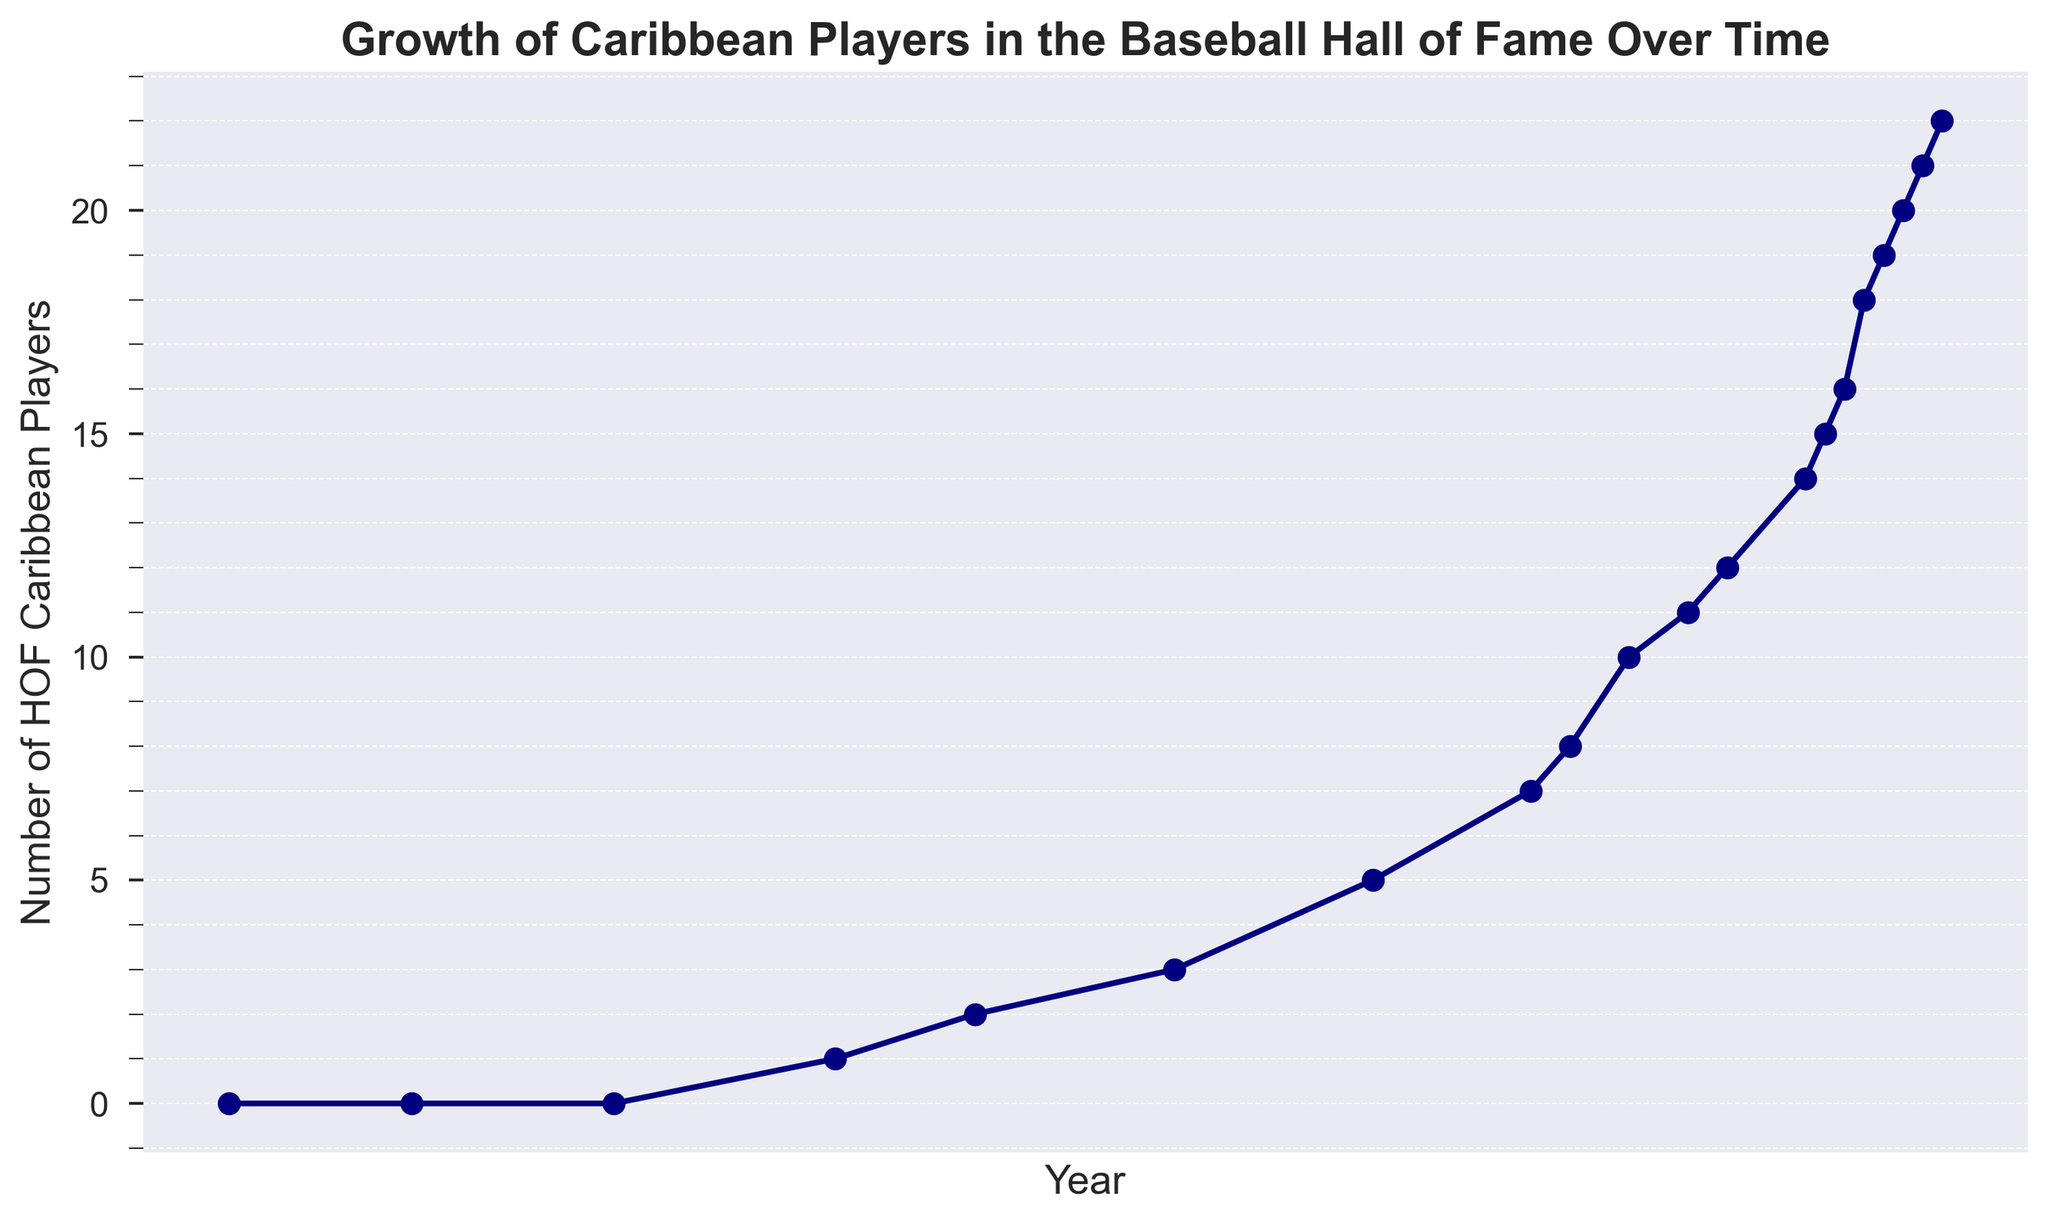What is the number of Caribbean players in the Hall of Fame in 1966? In 1966, the data point on the chart shows that there is 1 Caribbean player in the Hall of Fame.
Answer: 1 Which year saw the first Caribbean player inducted into the Hall of Fame? By examining the x-axis and y-axis values, 1966 is the year where the number of Caribbean players changes from 0 to 1, indicating the first induction.
Answer: 1966 How many Caribbean players were inducted from 2001 to 2022? From the chart, in 2001 there were 7 Caribbean players, and by 2022, it increased to 22. So, the number of players added is 22 - 7 = 15.
Answer: 15 Between which years did the number of Caribbean players in the Hall of Fame first double? Starting with 1 player in 1966, it doubled to 2 players by 1973.
Answer: 1966 and 1973 What is the average yearly increase in the number of Caribbean players in the Hall of Fame from 2011 to 2022? In 2011, there were 12 Caribbean players, and by 2022, there were 22. So, the increase is 22 - 12 = 10 over 11 years. The average yearly increase is 10 / 11 ≈ 0.91 players/year.
Answer: 0.91 In which decades did the number of Caribbean players in the Hall of Fame see the most growth? Observing the plot, significant growth periods correspond to the 1990s and 2000s where numbers increase substantially.
Answer: 1990s and 2000s What is the total number of new Caribbean players added to the Hall of Fame between 1993 and 2018? The number increased from 5 in 1993 to 18 in 2018, thus the total number added is 18 - 5 = 13.
Answer: 13 Between which consecutive years did the number of inducted Caribbean players not change? Observe the flat horizontal segments. Between 2019 and 2020, the number stays stable at 20.
Answer: 2019 and 2020 What's the percentage increase in Caribbean Hall of Fame players between 1983 and 2006? In 1983, there were 3 players, and by 2006 there were 10. The increase is 10 - 3 = 7. The percentage increase over this period is (7 / 3) * 100 ≈ 233.3%.
Answer: 233.3% How does the growth rate of Caribbean Hall of Fame players compare between the periods 2006-2011 and 2011-2016? From 2006 to 2011, the increase is from 10 to 12 players (2 players in 5 years). From 2011 to 2016, the increase is from 12 to 15 players (3 players in 5 years). So, the growth rate is higher from 2011 to 2016.
Answer: Growth rate is higher from 2011 to 2016 